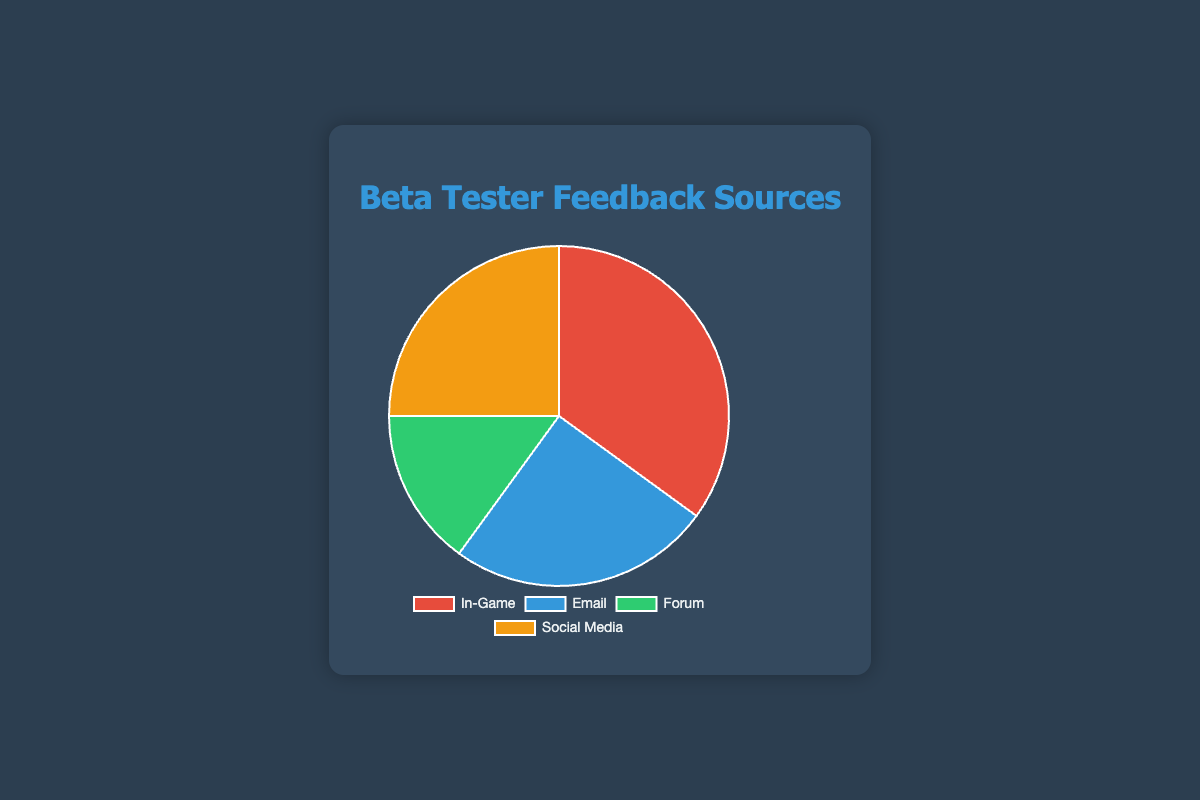What source provided the most feedback? Observe the sizes of the slices in the pie chart. The largest slice represents the "In-Game" source.
Answer: In-Game Which two sources provided the same amount of feedback? Look at the pie chart to identify the slices of the same size. Both "Email" and "Social Media" have equal-sized slices.
Answer: Email and Social Media What is the difference in feedback between the source with the most feedback and the source with the least feedback? The largest feedback source is "In-Game" with 35%, and the smallest is "Forum" with 15%. The difference is 35% - 15%.
Answer: 20% How much feedback, in total percentage, comes from "Email" and "Social Media" combined? Find the slices representing "Email" and "Social Media" (both 25%). Adding them together gives 25% + 25%.
Answer: 50% What percentage of feedback comes from the sources excluding "In-Game"? Sum the feedback from "Email" (25%), "Forum" (15%), and "Social Media" (25%). The total is 25% + 15% + 25%.
Answer: 65% Which source received less feedback than "In-Game" but more feedback than "Forum"? Determine "Forum" and "In-Game" feedback percentages: 15% for "Forum" and 35% for "In-Game". Both "Email" and "Social Media" fit between these values.
Answer: Email and Social Media What fraction of the total feedback does the "Forum" category represent? "Forum" feedback is 15% of the total feedback. As a fraction of 100%, this is 15/100.
Answer: 15/100 Which group has a larger share, "Forum" or "Email"? Compare the sizes of slices representing "Forum" and "Email." "Email" has a larger slice at 25% versus "Forum" at 15%.
Answer: Email 